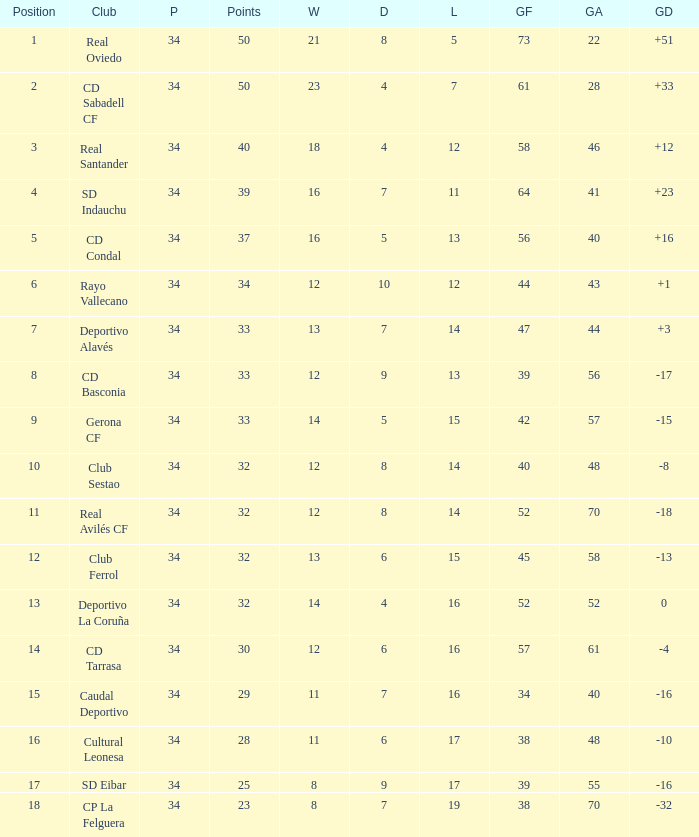I'm looking to parse the entire table for insights. Could you assist me with that? {'header': ['Position', 'Club', 'P', 'Points', 'W', 'D', 'L', 'GF', 'GA', 'GD'], 'rows': [['1', 'Real Oviedo', '34', '50', '21', '8', '5', '73', '22', '+51'], ['2', 'CD Sabadell CF', '34', '50', '23', '4', '7', '61', '28', '+33'], ['3', 'Real Santander', '34', '40', '18', '4', '12', '58', '46', '+12'], ['4', 'SD Indauchu', '34', '39', '16', '7', '11', '64', '41', '+23'], ['5', 'CD Condal', '34', '37', '16', '5', '13', '56', '40', '+16'], ['6', 'Rayo Vallecano', '34', '34', '12', '10', '12', '44', '43', '+1'], ['7', 'Deportivo Alavés', '34', '33', '13', '7', '14', '47', '44', '+3'], ['8', 'CD Basconia', '34', '33', '12', '9', '13', '39', '56', '-17'], ['9', 'Gerona CF', '34', '33', '14', '5', '15', '42', '57', '-15'], ['10', 'Club Sestao', '34', '32', '12', '8', '14', '40', '48', '-8'], ['11', 'Real Avilés CF', '34', '32', '12', '8', '14', '52', '70', '-18'], ['12', 'Club Ferrol', '34', '32', '13', '6', '15', '45', '58', '-13'], ['13', 'Deportivo La Coruña', '34', '32', '14', '4', '16', '52', '52', '0'], ['14', 'CD Tarrasa', '34', '30', '12', '6', '16', '57', '61', '-4'], ['15', 'Caudal Deportivo', '34', '29', '11', '7', '16', '34', '40', '-16'], ['16', 'Cultural Leonesa', '34', '28', '11', '6', '17', '38', '48', '-10'], ['17', 'SD Eibar', '34', '25', '8', '9', '17', '39', '55', '-16'], ['18', 'CP La Felguera', '34', '23', '8', '7', '19', '38', '70', '-32']]} Which Wins have a Goal Difference larger than 0, and Goals against larger than 40, and a Position smaller than 6, and a Club of sd indauchu? 16.0. 